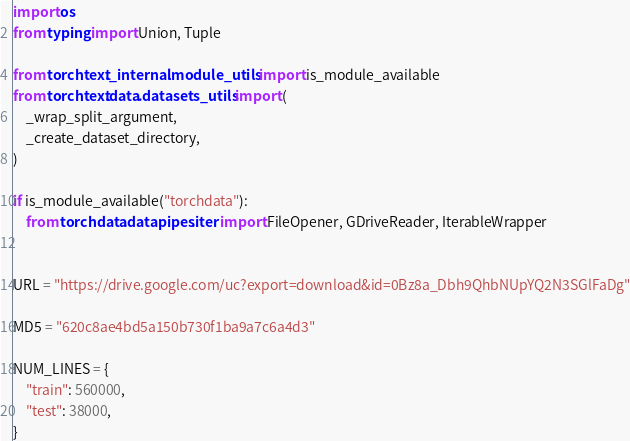<code> <loc_0><loc_0><loc_500><loc_500><_Python_>import os
from typing import Union, Tuple

from torchtext._internal.module_utils import is_module_available
from torchtext.data.datasets_utils import (
    _wrap_split_argument,
    _create_dataset_directory,
)

if is_module_available("torchdata"):
    from torchdata.datapipes.iter import FileOpener, GDriveReader, IterableWrapper


URL = "https://drive.google.com/uc?export=download&id=0Bz8a_Dbh9QhbNUpYQ2N3SGlFaDg"

MD5 = "620c8ae4bd5a150b730f1ba9a7c6a4d3"

NUM_LINES = {
    "train": 560000,
    "test": 38000,
}
</code> 